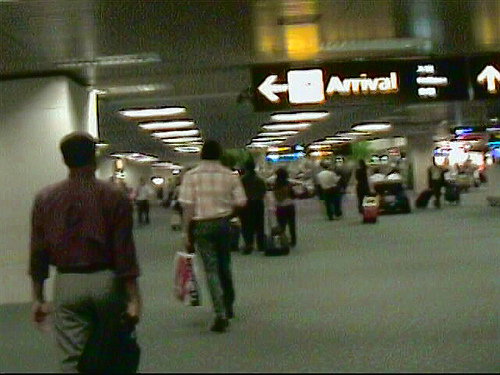Please transcribe the text information in this image. Arrival 